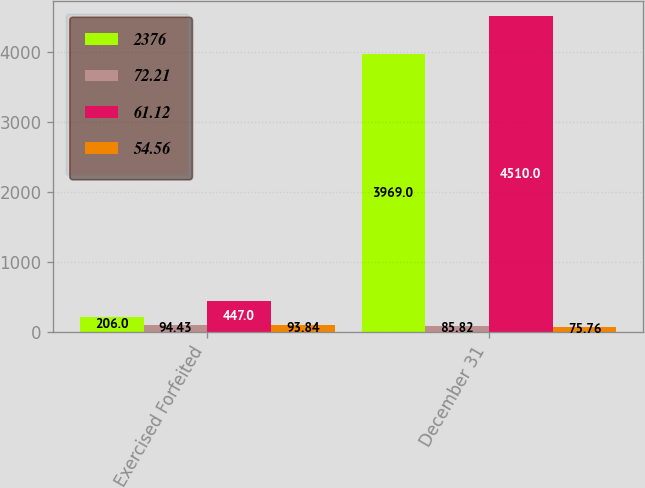Convert chart to OTSL. <chart><loc_0><loc_0><loc_500><loc_500><stacked_bar_chart><ecel><fcel>Exercised Forfeited<fcel>December 31<nl><fcel>2376<fcel>206<fcel>3969<nl><fcel>72.21<fcel>94.43<fcel>85.82<nl><fcel>61.12<fcel>447<fcel>4510<nl><fcel>54.56<fcel>93.84<fcel>75.76<nl></chart> 